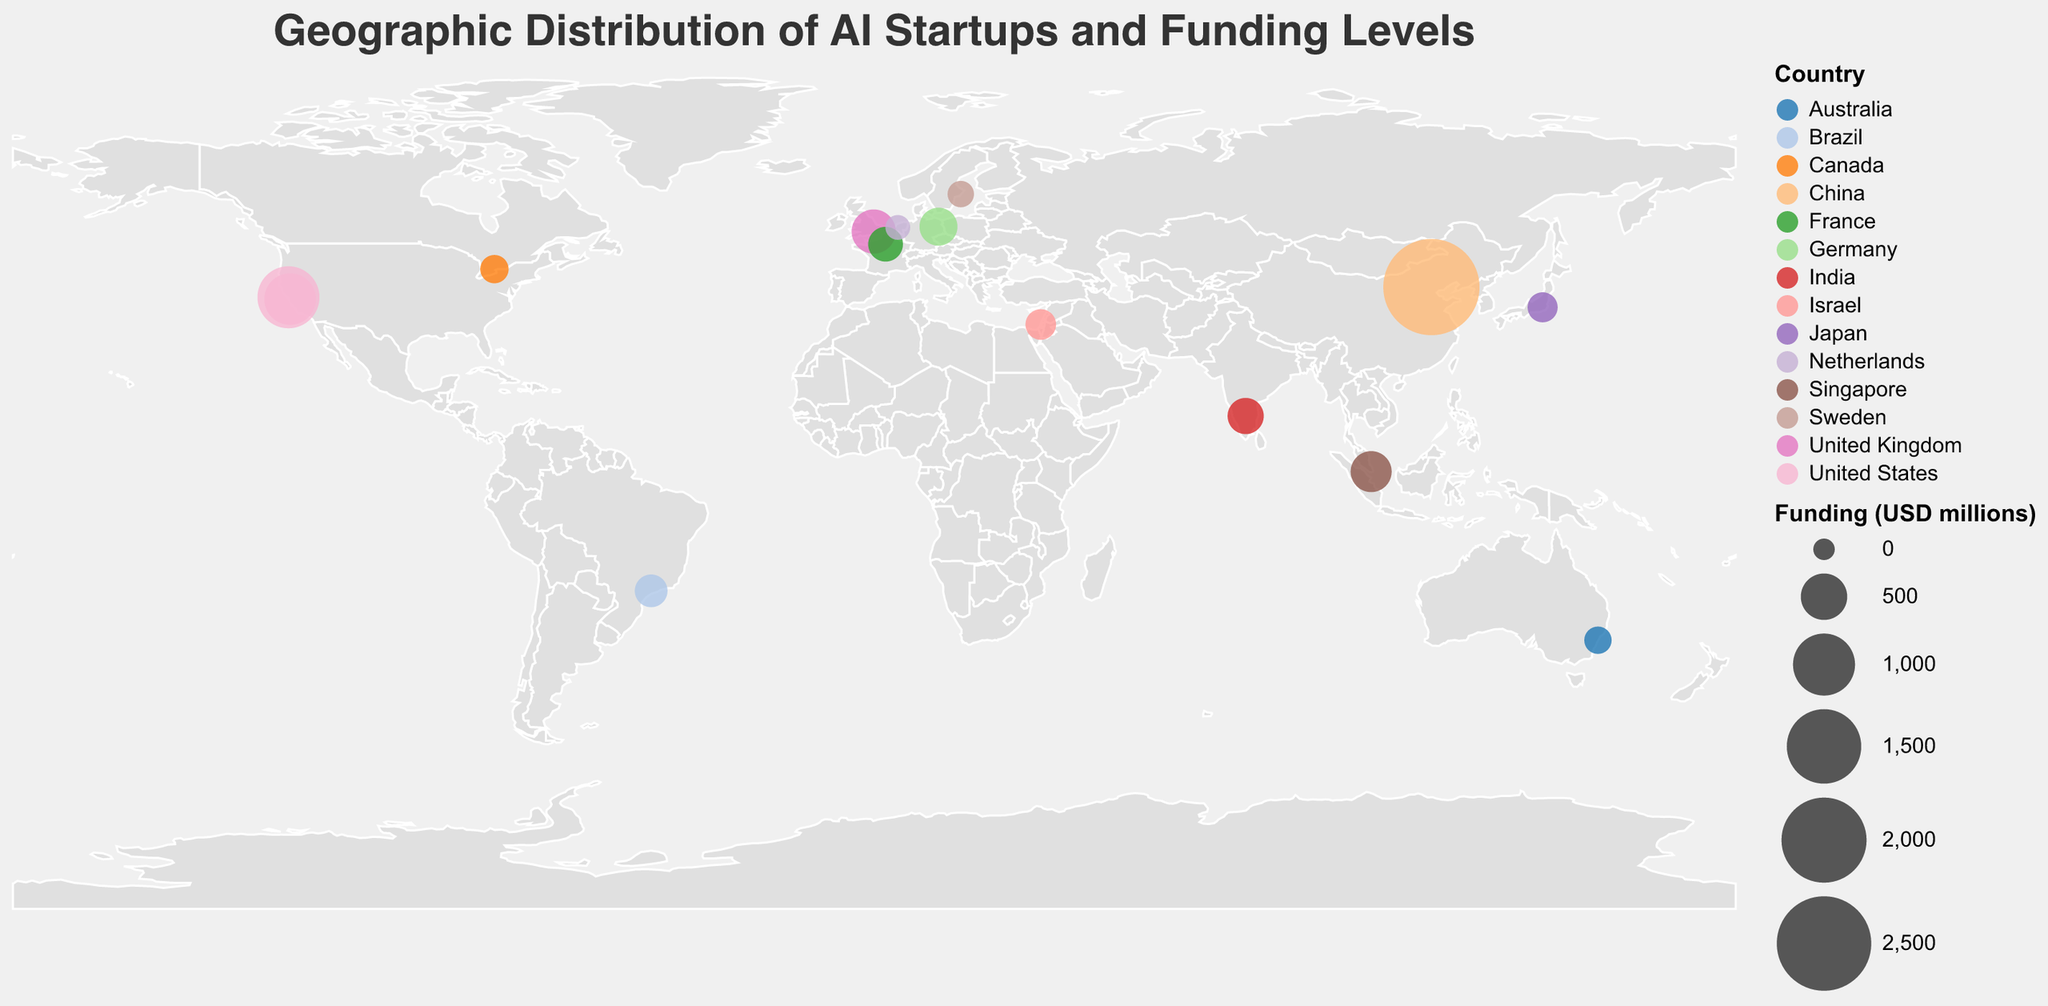What is the total funding (in USD millions) for AI startups in the United States? Combine the funding amounts for OpenAI ($1000M) and DeepMind ($650M), both located in the United States. So, $1000M + $650M = $1650M.
Answer: 1650 Which country has the AI startup that received the highest funding? SenseTime in Beijing, China, received the highest funding of $2600M.
Answer: China How many countries are represented in the figure, and which ones are they? Count the unique countries from the data points: United States, United Kingdom, China, Israel, Canada, Germany, France, Japan, India, Singapore, Australia, Sweden, Netherlands, Brazil. There are 14 countries in total.
Answer: 14 countries: United States, United Kingdom, China, Israel, Canada, Germany, France, Japan, India, Singapore, Australia, Sweden, Netherlands, Brazil What is the average funding of AI startups in countries outside of the United States? Exclude the United States and sum the funding for each remaining country: $440M (UK), $2600M (China), $140M (Israel), $100M (Canada), $290M (Germany), $220M (France), $130M (Japan), $250M (India), $360M (Singapore), $85M (Australia), $70M (Sweden), $45M (Netherlands), $180M (Brazil). Total funding: $4910M. Number of countries: 13. Average funding = $4910M / 13 = approximately $377.69M.
Answer: Approximately $377.69M Which city has the second highest funded AI startup? The city with the highest funding is Beijing (SenseTime, $2600M). The second highest is San Francisco (OpenAI, $1000M).
Answer: San Francisco Compare the funding amounts of AI startups in Europe. Which one has received the most funding? Compare funding amounts in European cities: London (Graphcore, $440M), Berlin (Celonis, $290M), Paris (Shift Technology, $220M), Stockholm (Peltarion, $70M), Amsterdam (Aigent, $45M). London has the highest funding with $440M.
Answer: London What is the combined total funding for AI startups in Asia? Sum the funding amounts for cities in Asia: Beijing (SenseTime, $2600M), Tokyo (Preferred Networks, $130M), Bangalore (Ola Electric, $250M), Singapore (Trax, $360M). Total funding = $2600M + $130M + $250M + $360M = $3340M.
Answer: 3340 How many cities have AI startups with more than $500M in funding? Identify the cities: San Francisco (OpenAI, $1000M), Mountain View (DeepMind, $650M), Beijing (SenseTime, $2600M). There are 3 cities.
Answer: 3 Which startup has the lowest funding and which city is it located in? The startup with the lowest funding is Aigent with $45M, located in Amsterdam, Netherlands.
Answer: Aigent in Amsterdam 